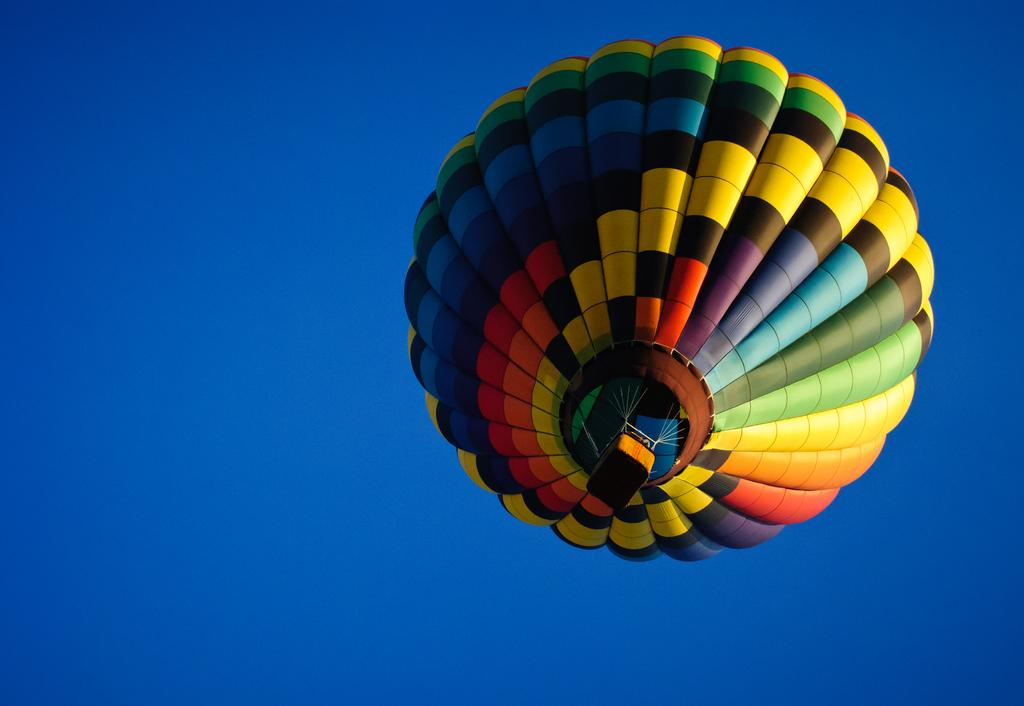What is the main subject of the picture? The main subject of the picture is a hot air balloon. What is the weather like in the image? The sky is sunny in the image. What type of sound can be heard coming from the hot air balloon in the image? There is no sound present in the image, as it is a still picture. What event is taking place in the image involving the hot air balloon? The image does not depict any specific event; it simply shows a hot air balloon in the sky. 